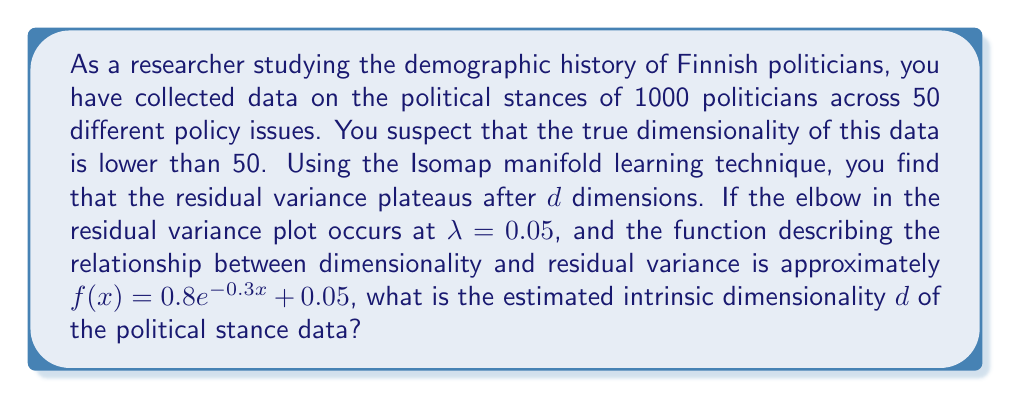Teach me how to tackle this problem. To solve this problem, we need to use the given information and the properties of the Isomap manifold learning technique:

1) The residual variance plateaus after $d$ dimensions, which indicates the intrinsic dimensionality of the data.

2) The elbow in the residual variance plot occurs at $\lambda = 0.05$.

3) The function describing the relationship between dimensionality and residual variance is:

   $$f(x) = 0.8e^{-0.3x} + 0.05$$

To find $d$, we need to solve the equation:

$$f(d) = \lambda$$

Substituting the given values:

$$0.8e^{-0.3d} + 0.05 = 0.05$$

Simplifying:

$$0.8e^{-0.3d} = 0$$

Taking the natural logarithm of both sides:

$$\ln(0.8) - 0.3d = \ln(0)$$

However, $\ln(0)$ is undefined. This means that the equation doesn't have an exact solution, which is expected as we're dealing with an approximation.

In practice, we would look for the point where the function gets very close to 0.05. We can do this by solving:

$$0.8e^{-0.3d} = 0.0001$$

Taking the natural logarithm:

$$\ln(0.8) - 0.3d = \ln(0.0001)$$

$$-0.223 - 0.3d = -9.21$$

Solving for $d$:

$$-0.3d = -9.21 + 0.223$$
$$-0.3d = -8.987$$
$$d = 29.96$$

Rounding to the nearest integer, we get $d = 30$.
Answer: The estimated intrinsic dimensionality of the political stance data is 30 dimensions. 